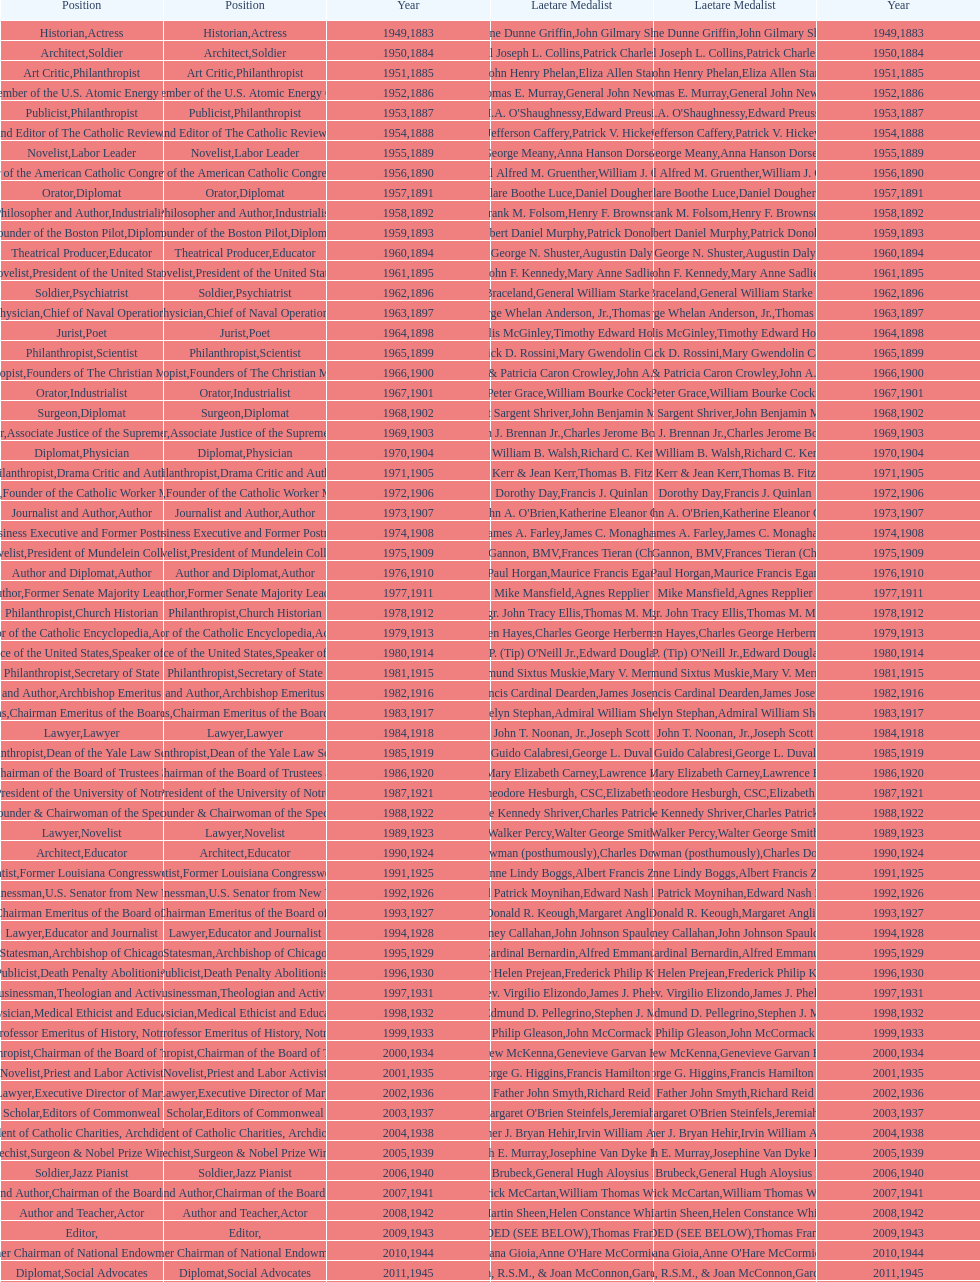How many attorneys have received the award between 1883 and 2014? 5. 